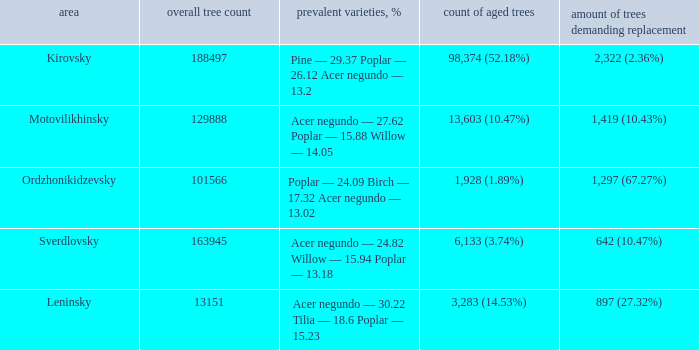What is the amount of trees, that require replacement when prevailing types, % is pine — 29.37 poplar — 26.12 acer negundo — 13.2? 2,322 (2.36%). 